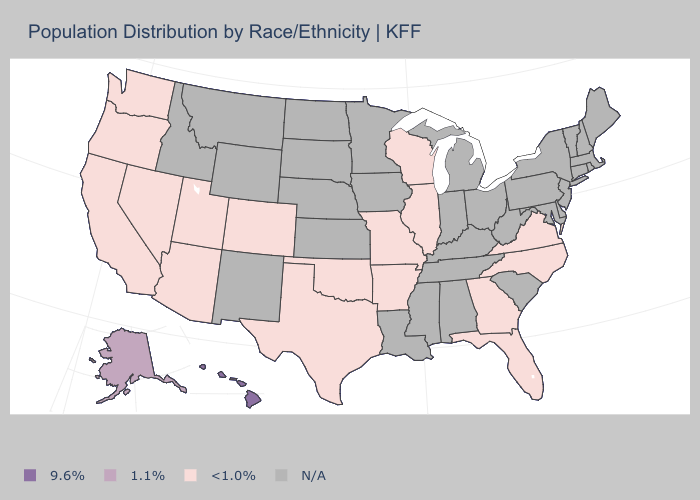Does Hawaii have the highest value in the USA?
Quick response, please. Yes. Does the map have missing data?
Answer briefly. Yes. Does the map have missing data?
Be succinct. Yes. What is the value of Missouri?
Answer briefly. <1.0%. Name the states that have a value in the range N/A?
Short answer required. Alabama, Connecticut, Delaware, Idaho, Indiana, Iowa, Kansas, Kentucky, Louisiana, Maine, Maryland, Massachusetts, Michigan, Minnesota, Mississippi, Montana, Nebraska, New Hampshire, New Jersey, New Mexico, New York, North Dakota, Ohio, Pennsylvania, Rhode Island, South Carolina, South Dakota, Tennessee, Vermont, West Virginia, Wyoming. Name the states that have a value in the range 1.1%?
Short answer required. Alaska. What is the value of Rhode Island?
Keep it brief. N/A. Which states have the highest value in the USA?
Keep it brief. Hawaii. What is the highest value in the USA?
Give a very brief answer. 9.6%. What is the value of Hawaii?
Give a very brief answer. 9.6%. Does Hawaii have the highest value in the USA?
Quick response, please. Yes. Name the states that have a value in the range N/A?
Keep it brief. Alabama, Connecticut, Delaware, Idaho, Indiana, Iowa, Kansas, Kentucky, Louisiana, Maine, Maryland, Massachusetts, Michigan, Minnesota, Mississippi, Montana, Nebraska, New Hampshire, New Jersey, New Mexico, New York, North Dakota, Ohio, Pennsylvania, Rhode Island, South Carolina, South Dakota, Tennessee, Vermont, West Virginia, Wyoming. Name the states that have a value in the range N/A?
Concise answer only. Alabama, Connecticut, Delaware, Idaho, Indiana, Iowa, Kansas, Kentucky, Louisiana, Maine, Maryland, Massachusetts, Michigan, Minnesota, Mississippi, Montana, Nebraska, New Hampshire, New Jersey, New Mexico, New York, North Dakota, Ohio, Pennsylvania, Rhode Island, South Carolina, South Dakota, Tennessee, Vermont, West Virginia, Wyoming. What is the highest value in the USA?
Write a very short answer. 9.6%. What is the value of North Dakota?
Give a very brief answer. N/A. 